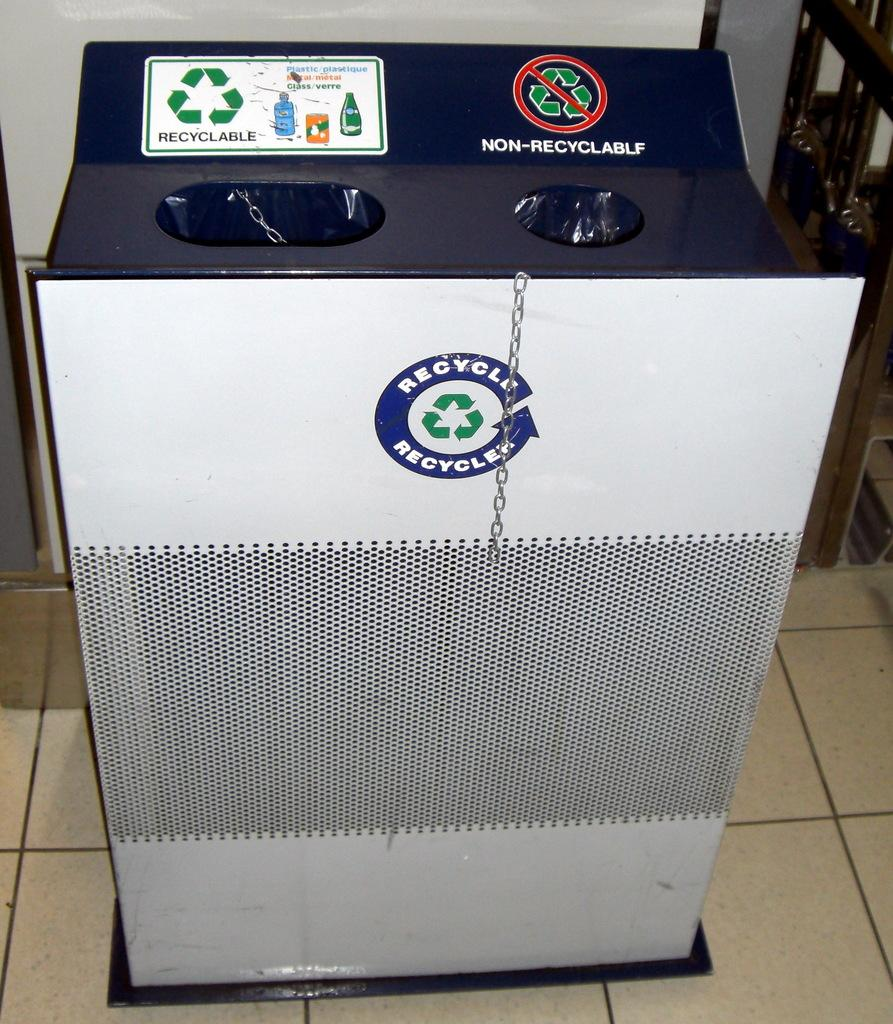<image>
Relay a brief, clear account of the picture shown. A large trash receptacle is separated into two sections, one labeled recyclable and the other non-recyclable. 